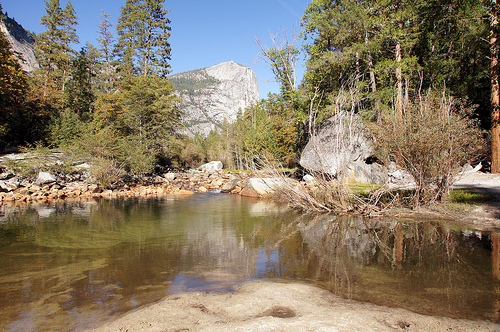<image>
Is the tree behind the rock? No. The tree is not behind the rock. From this viewpoint, the tree appears to be positioned elsewhere in the scene. 